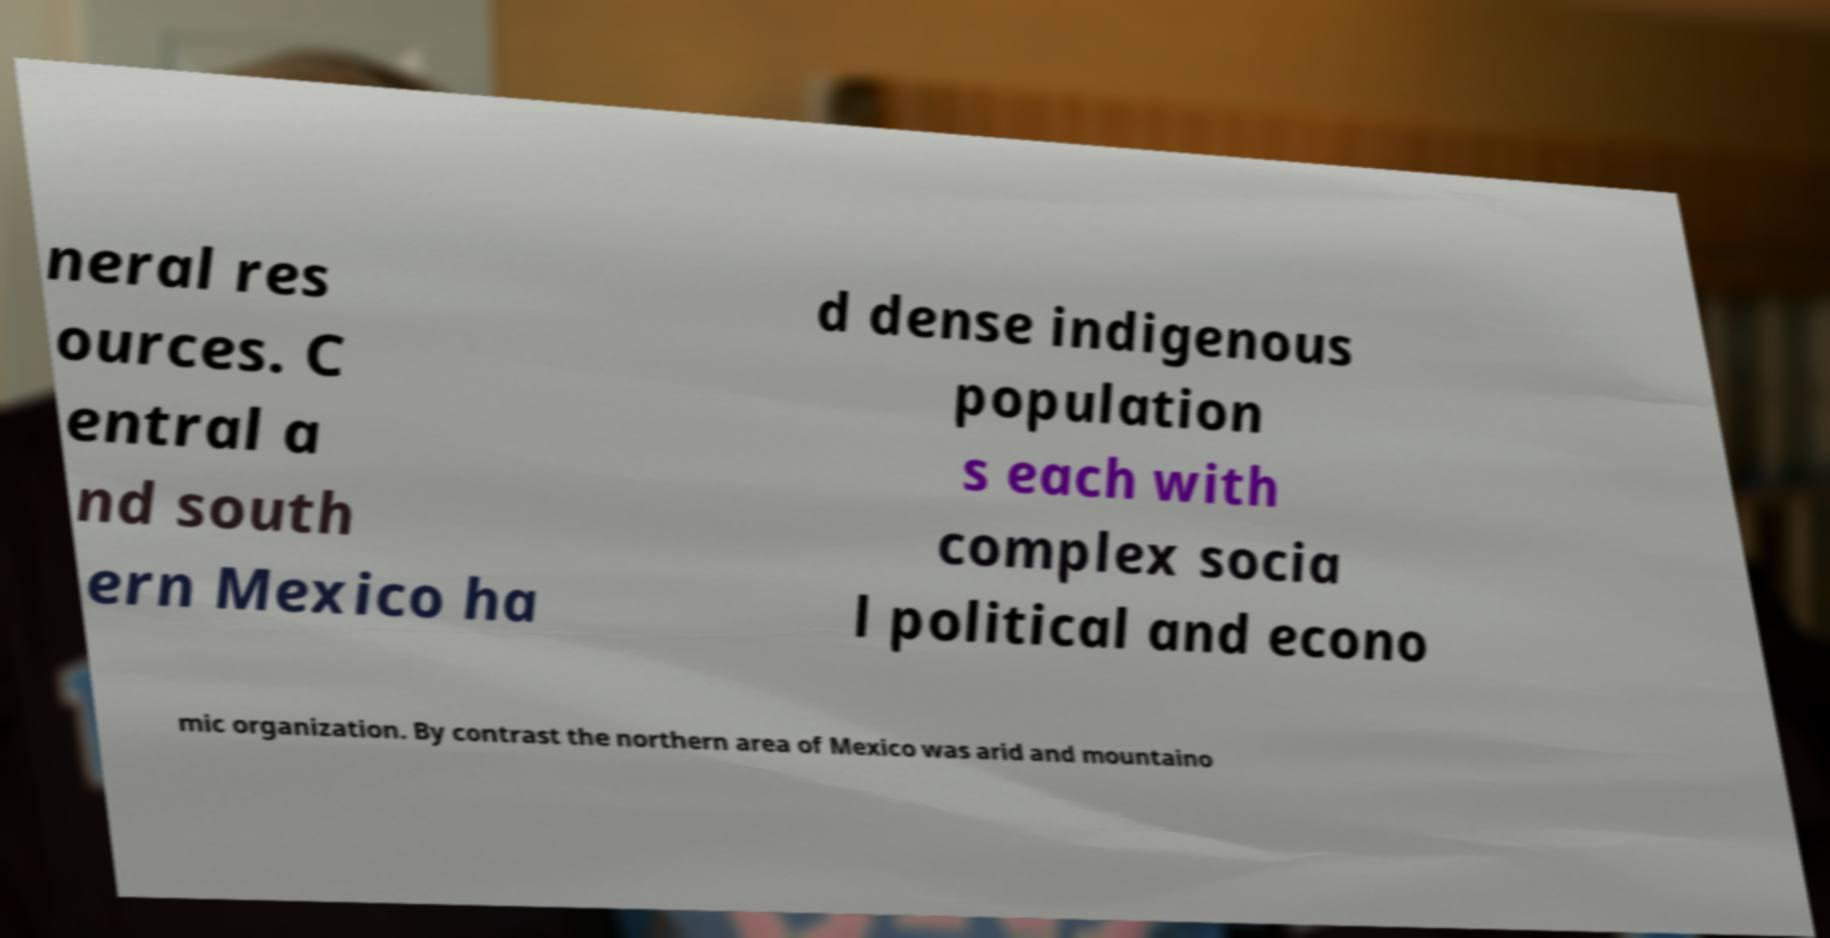Could you assist in decoding the text presented in this image and type it out clearly? neral res ources. C entral a nd south ern Mexico ha d dense indigenous population s each with complex socia l political and econo mic organization. By contrast the northern area of Mexico was arid and mountaino 